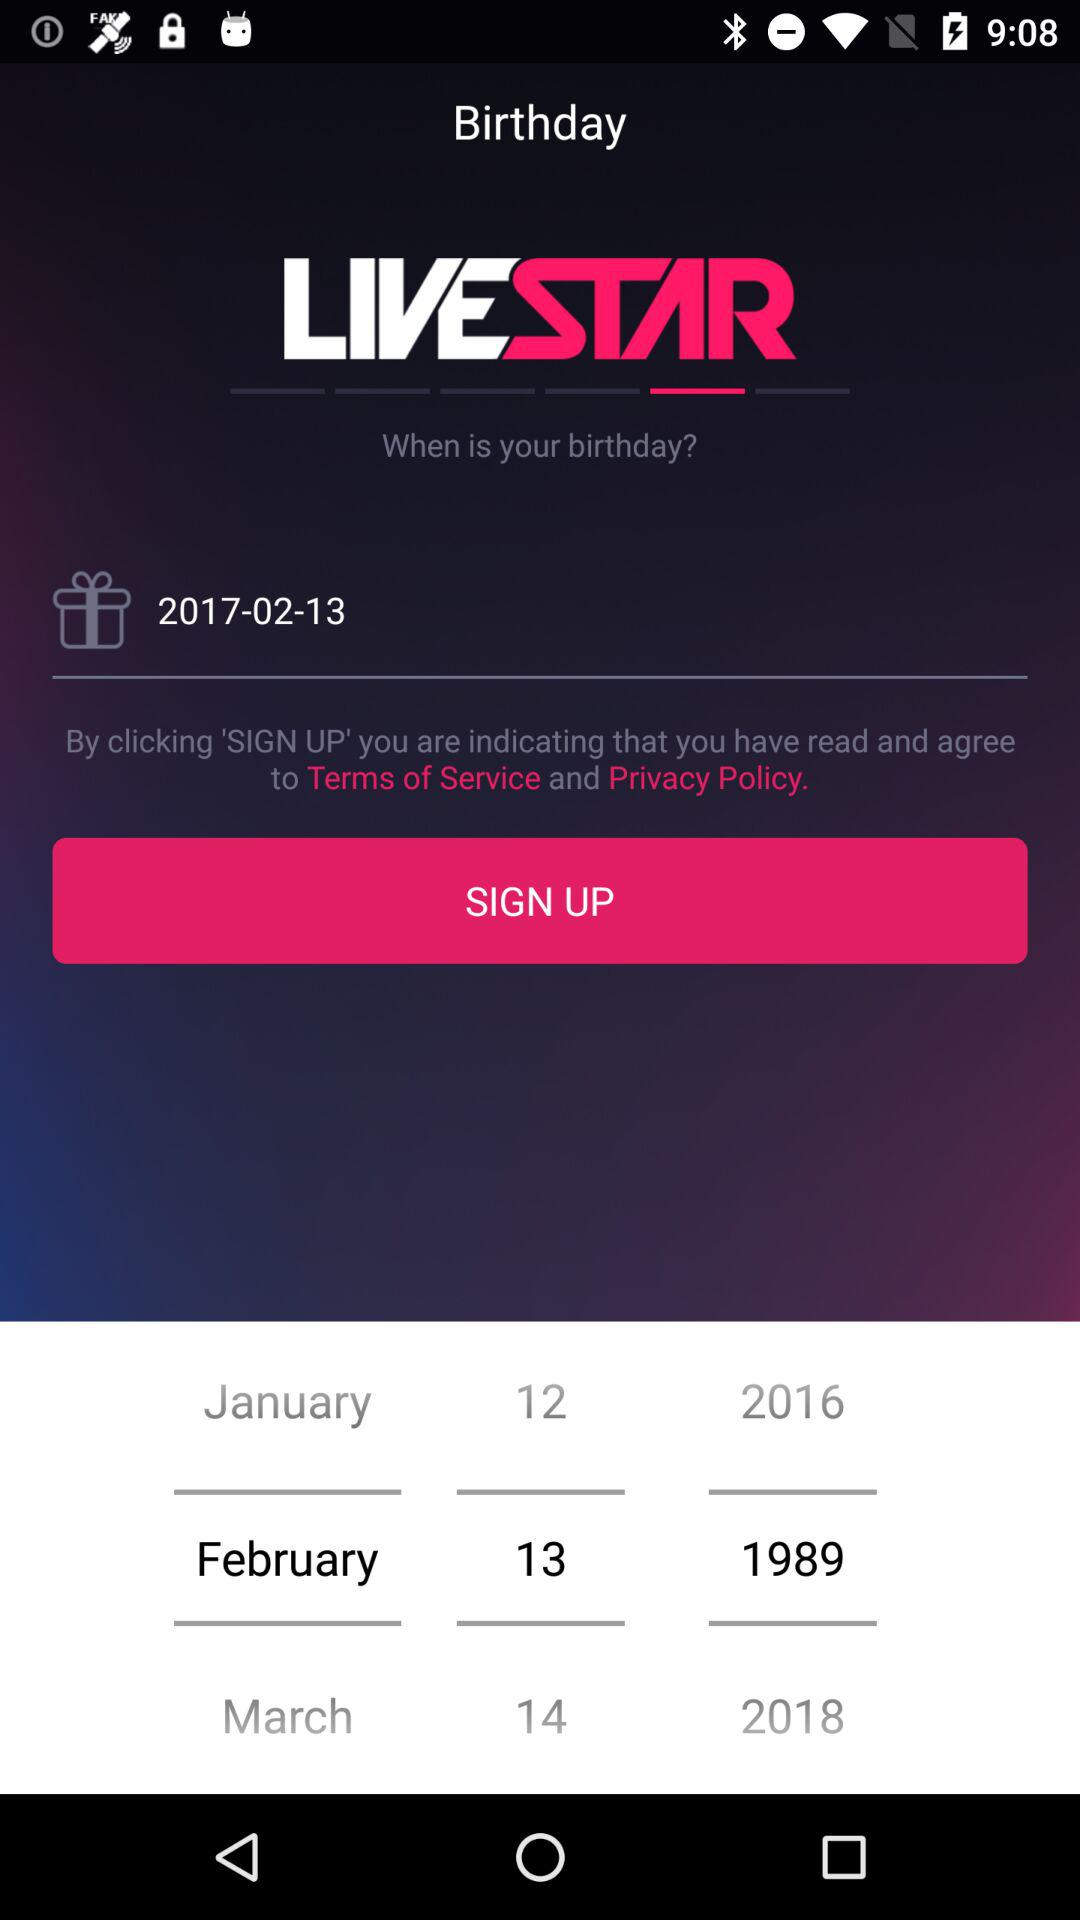How many months are available for the user to select?
Answer the question using a single word or phrase. 12 